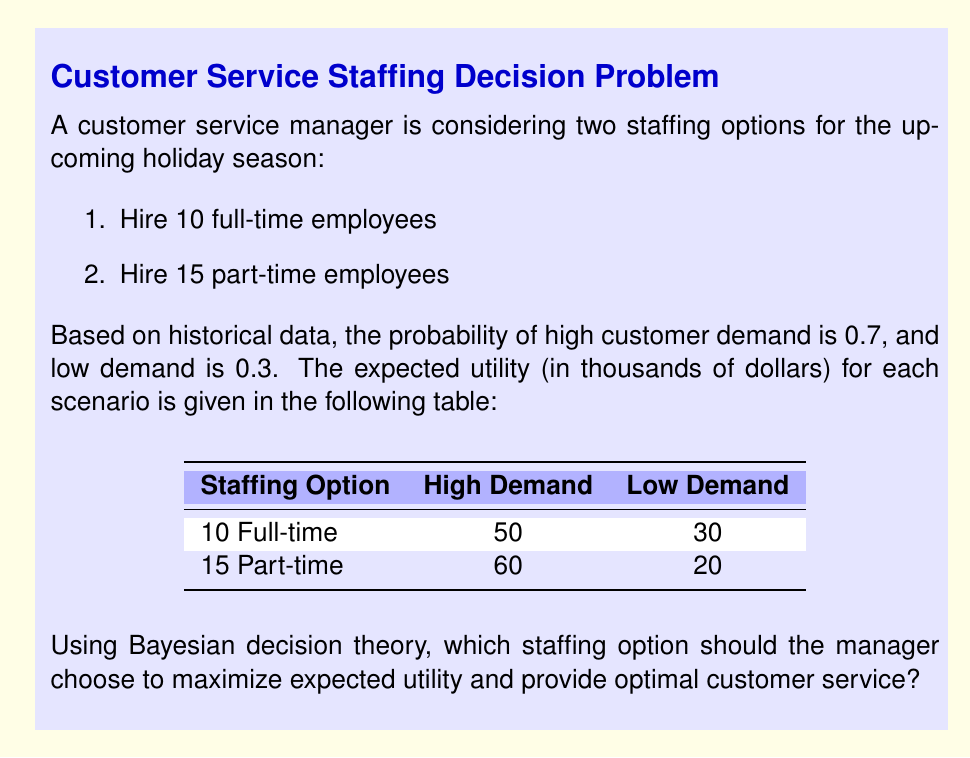What is the answer to this math problem? To solve this problem using Bayesian decision theory, we need to calculate the expected utility for each staffing option and choose the one with the higher value. Let's follow these steps:

1. Calculate the expected utility for hiring 10 full-time employees:

   $$ E(U_{full}) = P(high) \cdot U(full|high) + P(low) \cdot U(full|low) $$
   $$ E(U_{full}) = 0.7 \cdot 50 + 0.3 \cdot 30 $$
   $$ E(U_{full}) = 35 + 9 = 44 $$

2. Calculate the expected utility for hiring 15 part-time employees:

   $$ E(U_{part}) = P(high) \cdot U(part|high) + P(low) \cdot U(part|low) $$
   $$ E(U_{part}) = 0.7 \cdot 60 + 0.3 \cdot 20 $$
   $$ E(U_{part}) = 42 + 6 = 48 $$

3. Compare the expected utilities:

   $E(U_{part}) = 48 > E(U_{full}) = 44$

Therefore, hiring 15 part-time employees has a higher expected utility.
Answer: Hire 15 part-time employees 